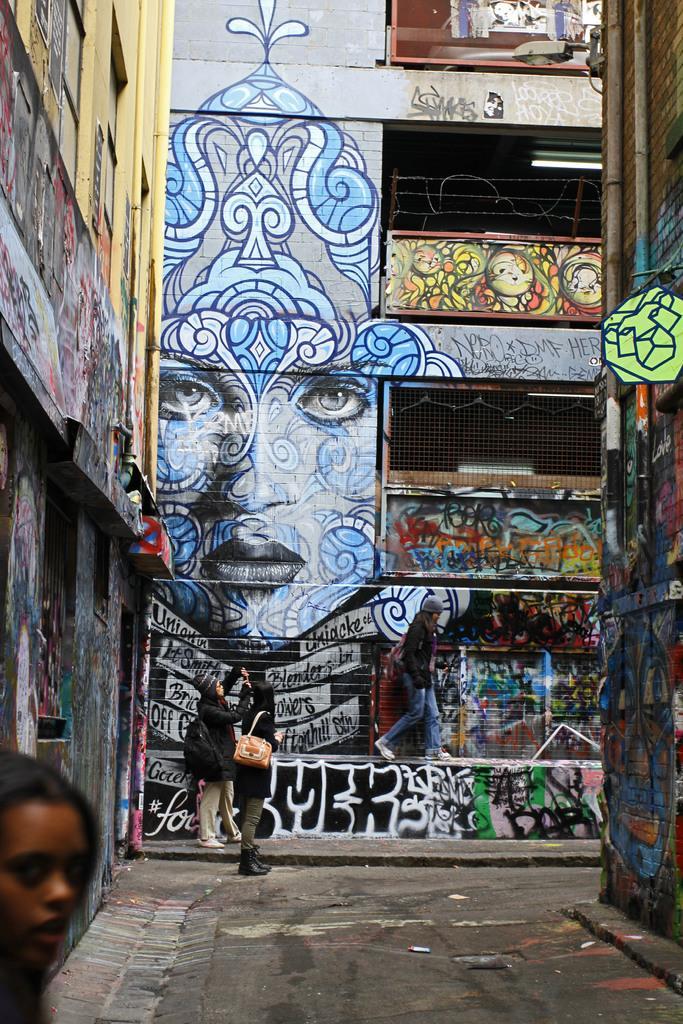How would you summarize this image in a sentence or two? In this image there are two people standing on the floor. Beside them there is a building on which there is graphite. On the left side bottom there is a girl. In the middle there is a girl who is walking on the wall. At the top there is a tube light. 